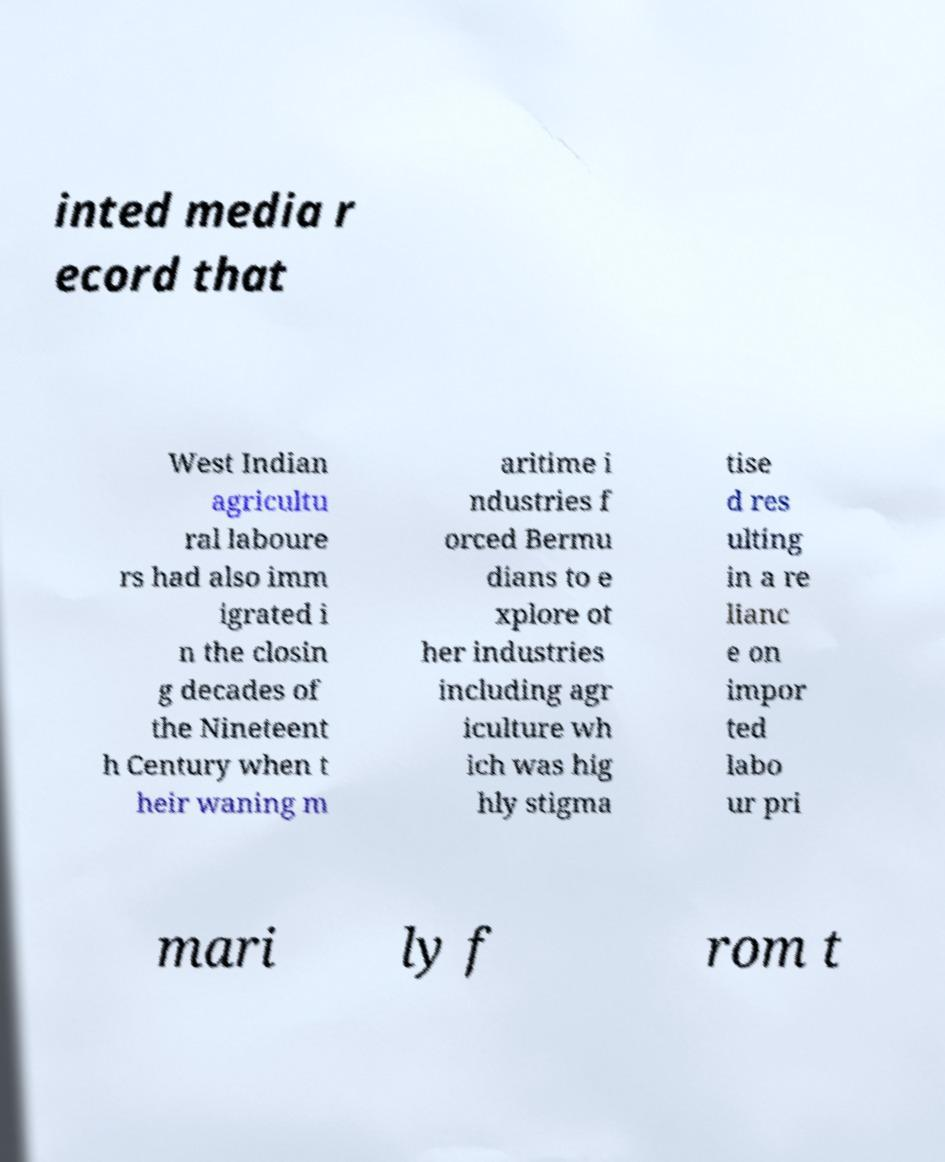Please read and relay the text visible in this image. What does it say? inted media r ecord that West Indian agricultu ral laboure rs had also imm igrated i n the closin g decades of the Nineteent h Century when t heir waning m aritime i ndustries f orced Bermu dians to e xplore ot her industries including agr iculture wh ich was hig hly stigma tise d res ulting in a re lianc e on impor ted labo ur pri mari ly f rom t 